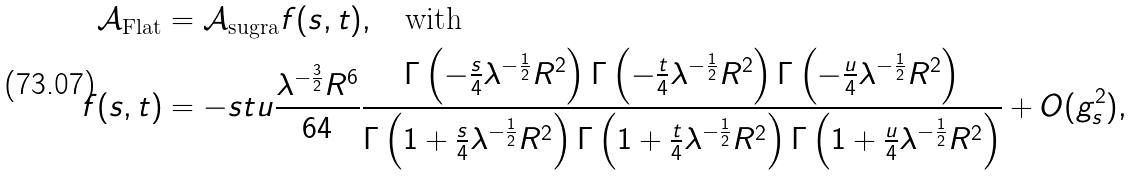<formula> <loc_0><loc_0><loc_500><loc_500>\mathcal { A } _ { \text {Flat} } & = \mathcal { A } _ { \text {sugra} } f ( s , t ) , \quad \text {with} \\ f ( s , t ) & = - s t u \frac { \lambda ^ { - \frac { 3 } { 2 } } R ^ { 6 } } { 6 4 } \frac { \Gamma \left ( - \frac { s } { 4 } \lambda ^ { - \frac { 1 } { 2 } } R ^ { 2 } \right ) \Gamma \left ( - \frac { t } { 4 } \lambda ^ { - \frac { 1 } { 2 } } R ^ { 2 } \right ) \Gamma \left ( - \frac { u } { 4 } \lambda ^ { - \frac { 1 } { 2 } } R ^ { 2 } \right ) } { \Gamma \left ( 1 + \frac { s } { 4 } \lambda ^ { - \frac { 1 } { 2 } } R ^ { 2 } \right ) \Gamma \left ( 1 + \frac { t } { 4 } \lambda ^ { - \frac { 1 } { 2 } } R ^ { 2 } \right ) \Gamma \left ( 1 + \frac { u } { 4 } \lambda ^ { - \frac { 1 } { 2 } } R ^ { 2 } \right ) } + O ( g _ { s } ^ { 2 } ) ,</formula> 